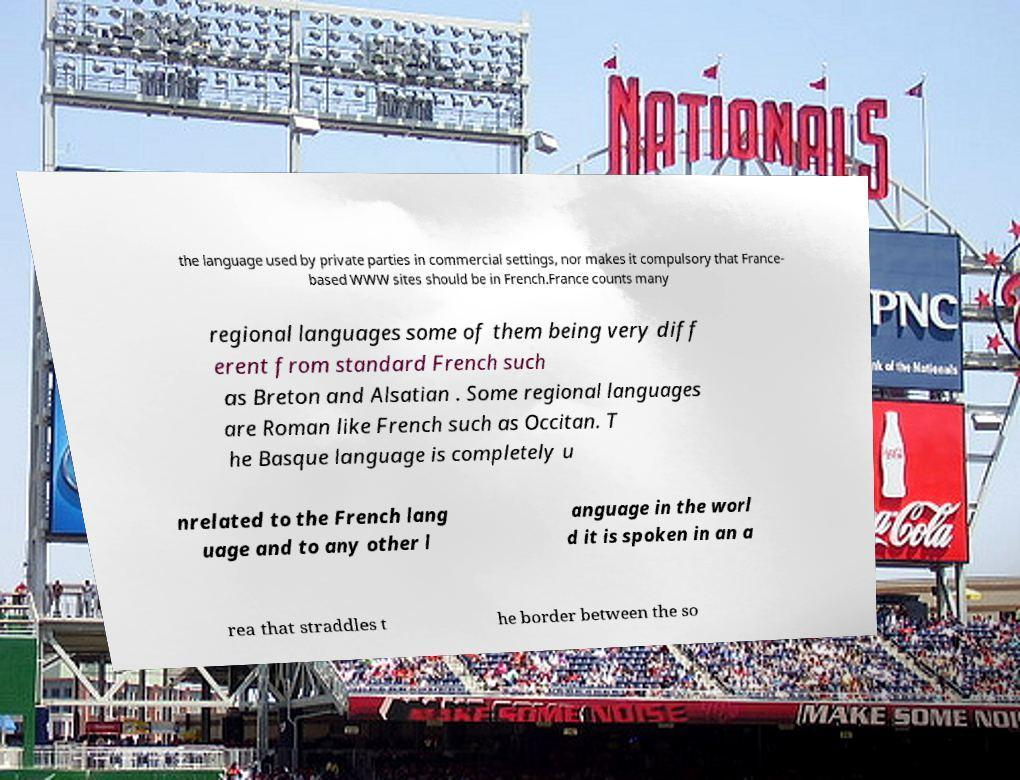Please identify and transcribe the text found in this image. the language used by private parties in commercial settings, nor makes it compulsory that France- based WWW sites should be in French.France counts many regional languages some of them being very diff erent from standard French such as Breton and Alsatian . Some regional languages are Roman like French such as Occitan. T he Basque language is completely u nrelated to the French lang uage and to any other l anguage in the worl d it is spoken in an a rea that straddles t he border between the so 